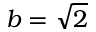<formula> <loc_0><loc_0><loc_500><loc_500>b = { \sqrt { 2 } }</formula> 